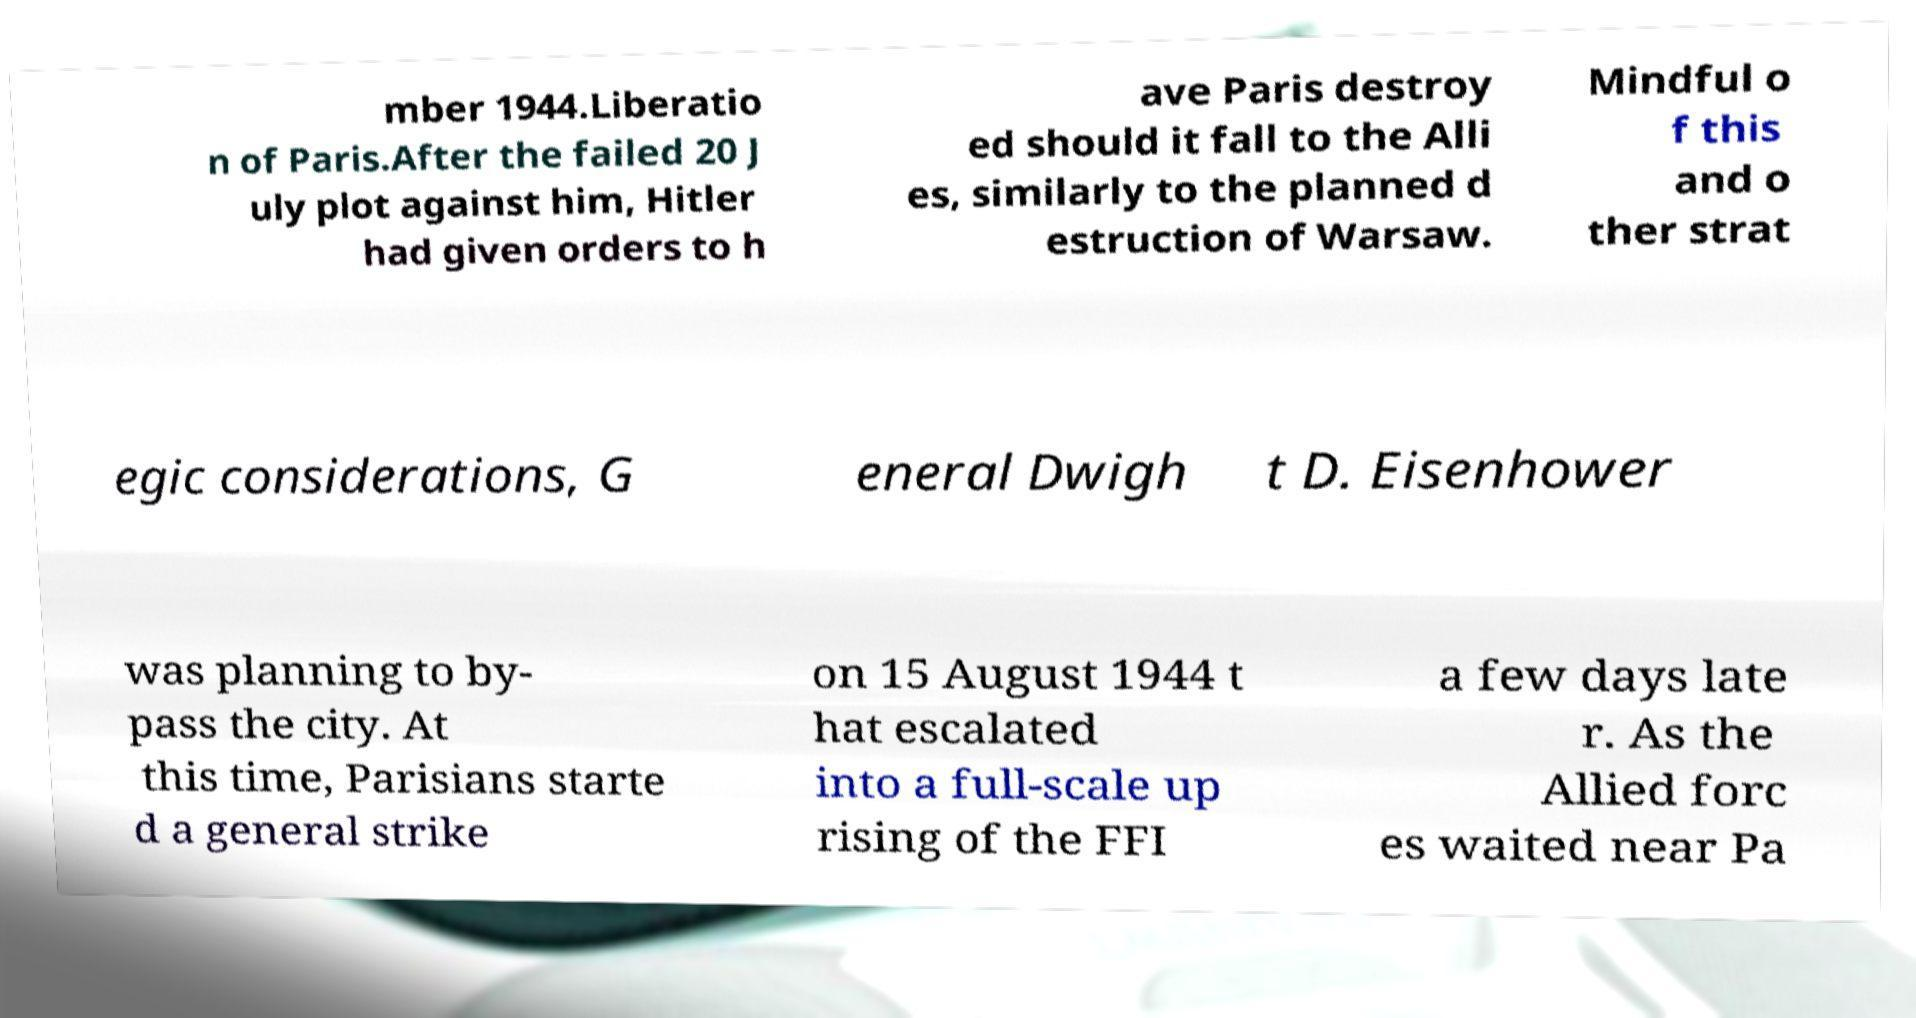Can you read and provide the text displayed in the image?This photo seems to have some interesting text. Can you extract and type it out for me? mber 1944.Liberatio n of Paris.After the failed 20 J uly plot against him, Hitler had given orders to h ave Paris destroy ed should it fall to the Alli es, similarly to the planned d estruction of Warsaw. Mindful o f this and o ther strat egic considerations, G eneral Dwigh t D. Eisenhower was planning to by- pass the city. At this time, Parisians starte d a general strike on 15 August 1944 t hat escalated into a full-scale up rising of the FFI a few days late r. As the Allied forc es waited near Pa 